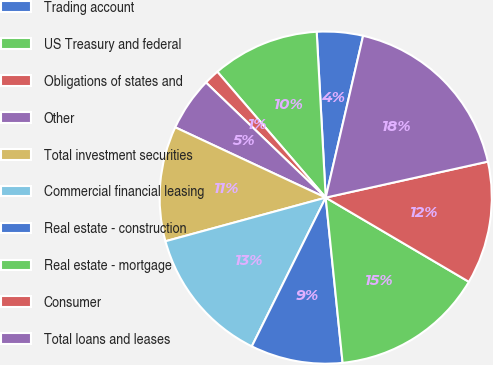Convert chart to OTSL. <chart><loc_0><loc_0><loc_500><loc_500><pie_chart><fcel>Trading account<fcel>US Treasury and federal<fcel>Obligations of states and<fcel>Other<fcel>Total investment securities<fcel>Commercial financial leasing<fcel>Real estate - construction<fcel>Real estate - mortgage<fcel>Consumer<fcel>Total loans and leases<nl><fcel>4.48%<fcel>10.45%<fcel>1.5%<fcel>5.23%<fcel>11.19%<fcel>13.43%<fcel>8.96%<fcel>14.92%<fcel>11.94%<fcel>17.91%<nl></chart> 